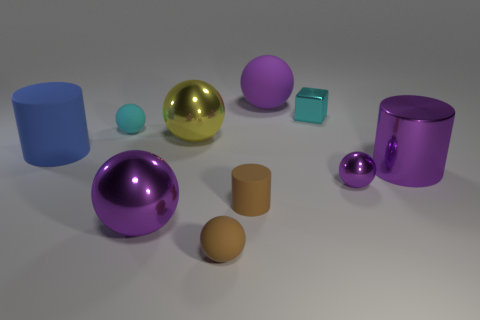Subtract all yellow cubes. How many purple spheres are left? 3 Subtract all brown spheres. How many spheres are left? 5 Subtract all yellow balls. How many balls are left? 5 Subtract all green spheres. Subtract all red blocks. How many spheres are left? 6 Subtract all cylinders. How many objects are left? 7 Subtract 1 cyan balls. How many objects are left? 9 Subtract all blue matte cylinders. Subtract all tiny green rubber cubes. How many objects are left? 9 Add 3 small shiny objects. How many small shiny objects are left? 5 Add 1 large purple objects. How many large purple objects exist? 4 